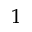<formula> <loc_0><loc_0><loc_500><loc_500>^ { 1 }</formula> 